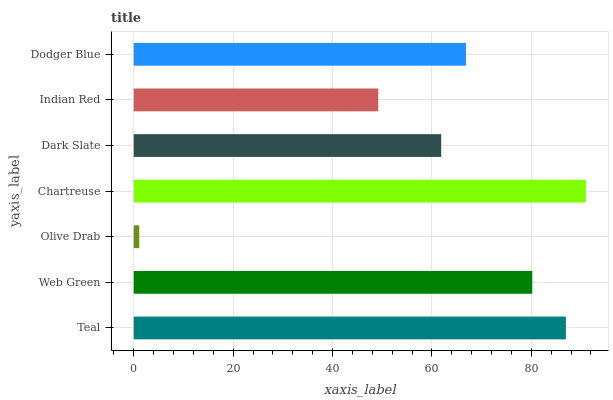Is Olive Drab the minimum?
Answer yes or no. Yes. Is Chartreuse the maximum?
Answer yes or no. Yes. Is Web Green the minimum?
Answer yes or no. No. Is Web Green the maximum?
Answer yes or no. No. Is Teal greater than Web Green?
Answer yes or no. Yes. Is Web Green less than Teal?
Answer yes or no. Yes. Is Web Green greater than Teal?
Answer yes or no. No. Is Teal less than Web Green?
Answer yes or no. No. Is Dodger Blue the high median?
Answer yes or no. Yes. Is Dodger Blue the low median?
Answer yes or no. Yes. Is Dark Slate the high median?
Answer yes or no. No. Is Chartreuse the low median?
Answer yes or no. No. 